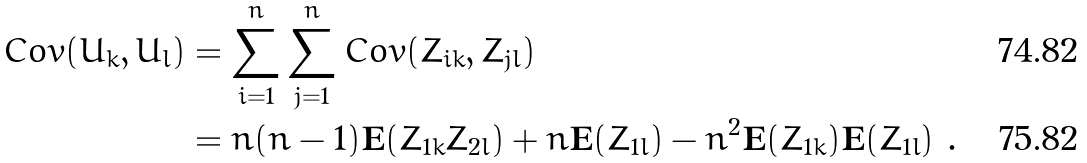<formula> <loc_0><loc_0><loc_500><loc_500>C o v ( U _ { k } , U _ { l } ) & = \sum _ { i = 1 } ^ { n } \sum _ { j = 1 } ^ { n } C o v ( Z _ { i k } , Z _ { j l } ) \\ & = n ( n - 1 ) \mathbf E ( Z _ { 1 k } Z _ { 2 l } ) + n \mathbf E ( Z _ { 1 l } ) - n ^ { 2 } \mathbf E ( Z _ { 1 k } ) \mathbf E ( Z _ { 1 l } ) \ .</formula> 